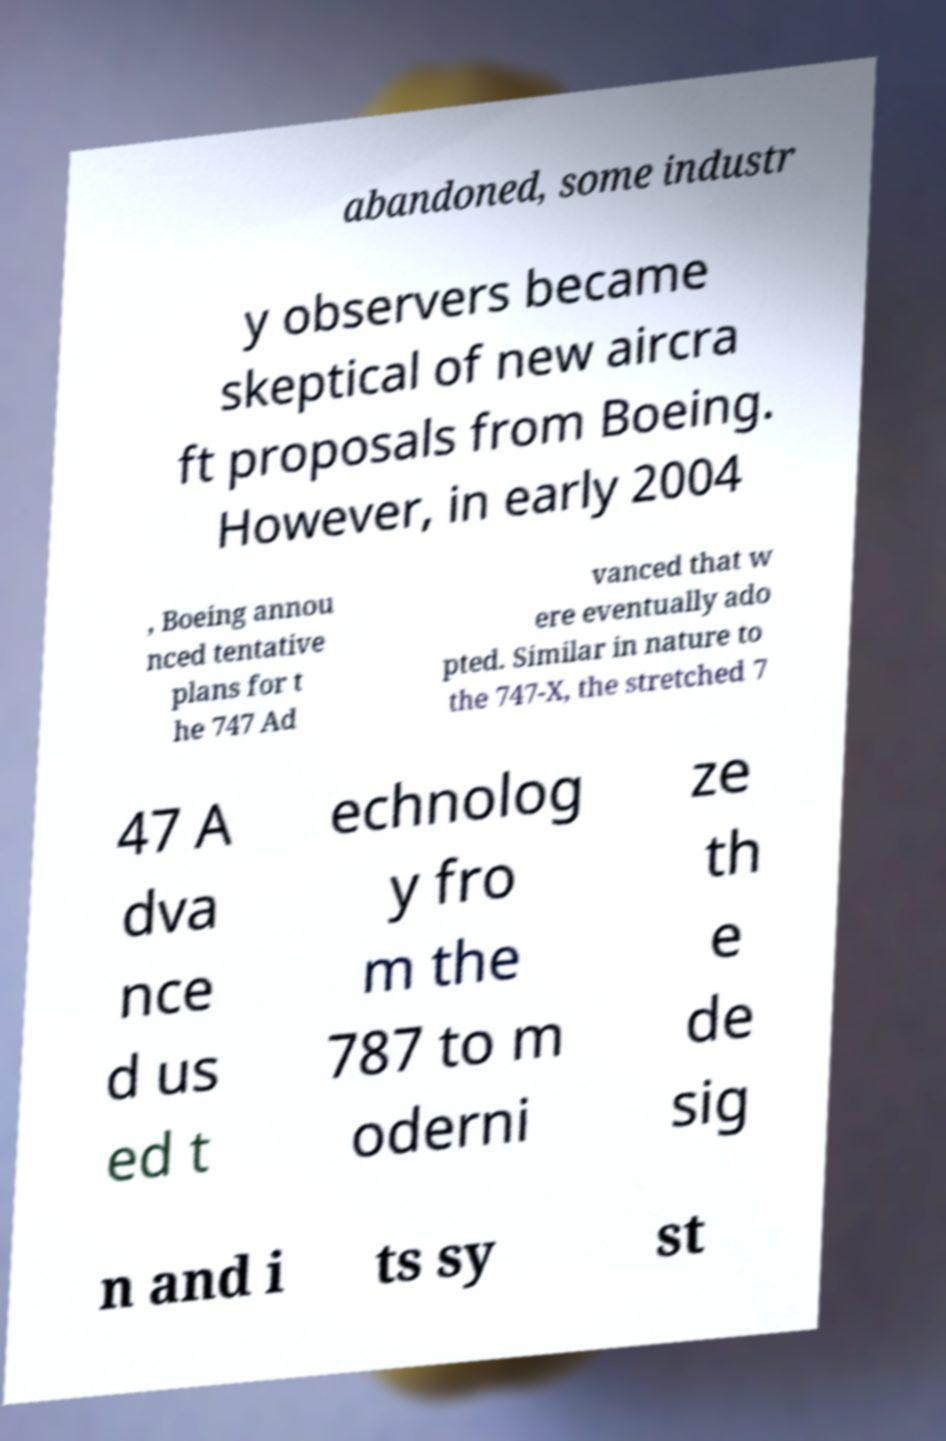What messages or text are displayed in this image? I need them in a readable, typed format. abandoned, some industr y observers became skeptical of new aircra ft proposals from Boeing. However, in early 2004 , Boeing annou nced tentative plans for t he 747 Ad vanced that w ere eventually ado pted. Similar in nature to the 747-X, the stretched 7 47 A dva nce d us ed t echnolog y fro m the 787 to m oderni ze th e de sig n and i ts sy st 